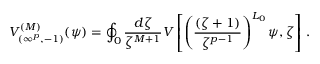<formula> <loc_0><loc_0><loc_500><loc_500>V _ { ( \infty ^ { p } , - 1 ) } ^ { ( M ) } ( \psi ) = \oint _ { 0 } \frac { d \zeta } { \zeta ^ { M + 1 } } V \left [ \left ( \frac { ( \zeta + 1 ) } { \zeta ^ { p - 1 } } \right ) ^ { L _ { 0 } } \psi , \zeta \right ] \, .</formula> 